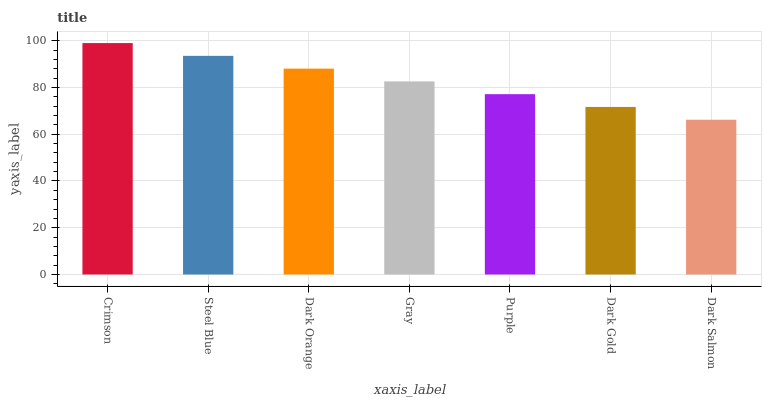Is Dark Salmon the minimum?
Answer yes or no. Yes. Is Crimson the maximum?
Answer yes or no. Yes. Is Steel Blue the minimum?
Answer yes or no. No. Is Steel Blue the maximum?
Answer yes or no. No. Is Crimson greater than Steel Blue?
Answer yes or no. Yes. Is Steel Blue less than Crimson?
Answer yes or no. Yes. Is Steel Blue greater than Crimson?
Answer yes or no. No. Is Crimson less than Steel Blue?
Answer yes or no. No. Is Gray the high median?
Answer yes or no. Yes. Is Gray the low median?
Answer yes or no. Yes. Is Dark Gold the high median?
Answer yes or no. No. Is Dark Salmon the low median?
Answer yes or no. No. 